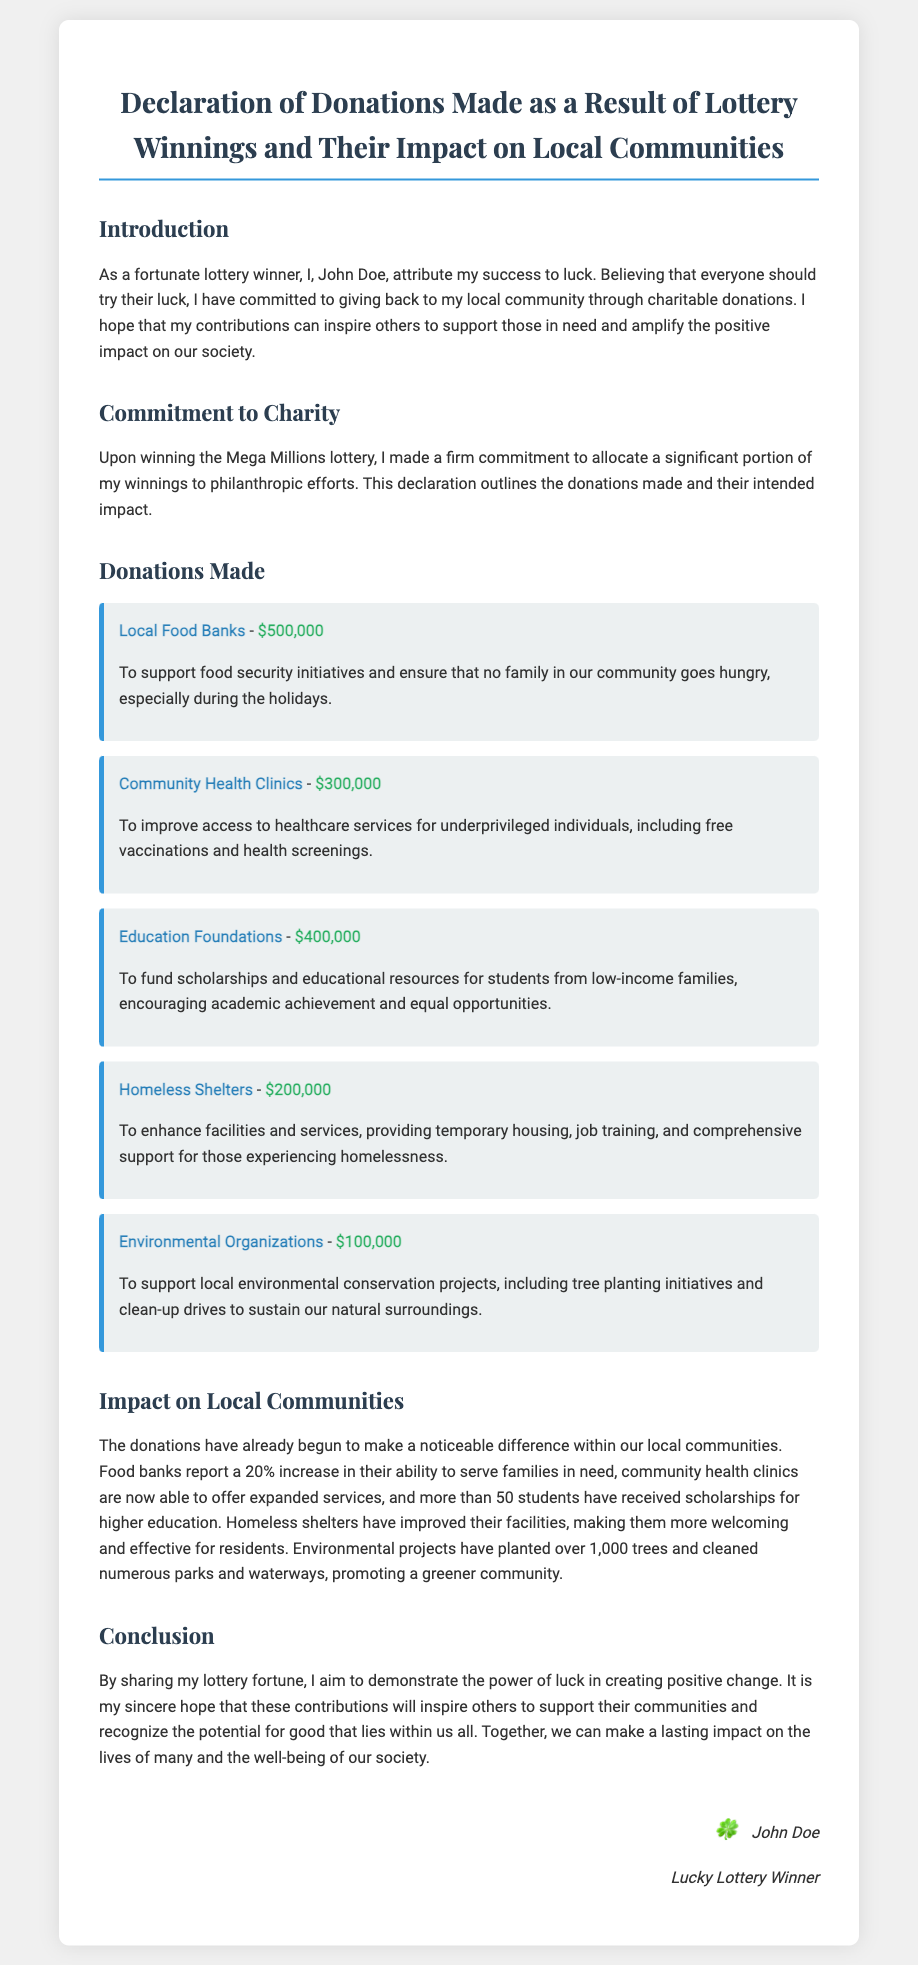What is the total amount donated to local food banks? The total amount donated to local food banks is specified in the document, which is $500,000.
Answer: $500,000 How much was allocated to community health clinics? The document states that $300,000 was allocated to community health clinics.
Answer: $300,000 What percentage increase in service capacity did food banks report? The document mentions a 20% increase in food banks' ability to serve families in need.
Answer: 20% Which charitable initiative received the most funding? The highest funding amount was allocated to local food banks, with $500,000.
Answer: Local Food Banks What is the name of the lottery won? The document specifies the lottery as Mega Millions.
Answer: Mega Millions How many students received scholarships from the donations? More than 50 students have received scholarships for higher education as stated in the document.
Answer: More than 50 What type of projects do environmental organizations focus on? The document specifies that they support local environmental conservation projects.
Answer: Environmental conservation What emotion does the winner hope to inspire in others? The winner hopes to inspire support for their communities through charitable contributions.
Answer: Support Who is the signatory of the document? The winner's name is mentioned at the end of the document.
Answer: John Doe 